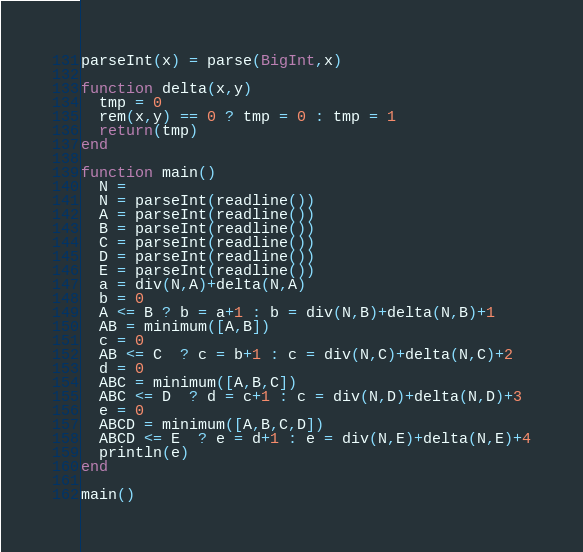<code> <loc_0><loc_0><loc_500><loc_500><_Julia_>parseInt(x) = parse(BigInt,x)

function delta(x,y)
  tmp = 0
  rem(x,y) == 0 ? tmp = 0 : tmp = 1
  return(tmp)
end

function main()
  N =
  N = parseInt(readline())
  A = parseInt(readline())
  B = parseInt(readline())
  C = parseInt(readline())
  D = parseInt(readline())
  E = parseInt(readline())
  a = div(N,A)+delta(N,A)
  b = 0
  A <= B ? b = a+1 : b = div(N,B)+delta(N,B)+1
  AB = minimum([A,B])
  c = 0 
  AB <= C  ? c = b+1 : c = div(N,C)+delta(N,C)+2
  d = 0
  ABC = minimum([A,B,C])
  ABC <= D  ? d = c+1 : c = div(N,D)+delta(N,D)+3
  e = 0
  ABCD = minimum([A,B,C,D])
  ABCD <= E  ? e = d+1 : e = div(N,E)+delta(N,E)+4
  println(e)
end

main()</code> 